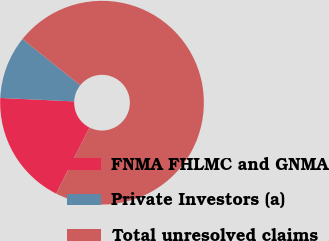Convert chart to OTSL. <chart><loc_0><loc_0><loc_500><loc_500><pie_chart><fcel>FNMA FHLMC and GNMA<fcel>Private Investors (a)<fcel>Total unresolved claims<nl><fcel>18.3%<fcel>10.0%<fcel>71.7%<nl></chart> 